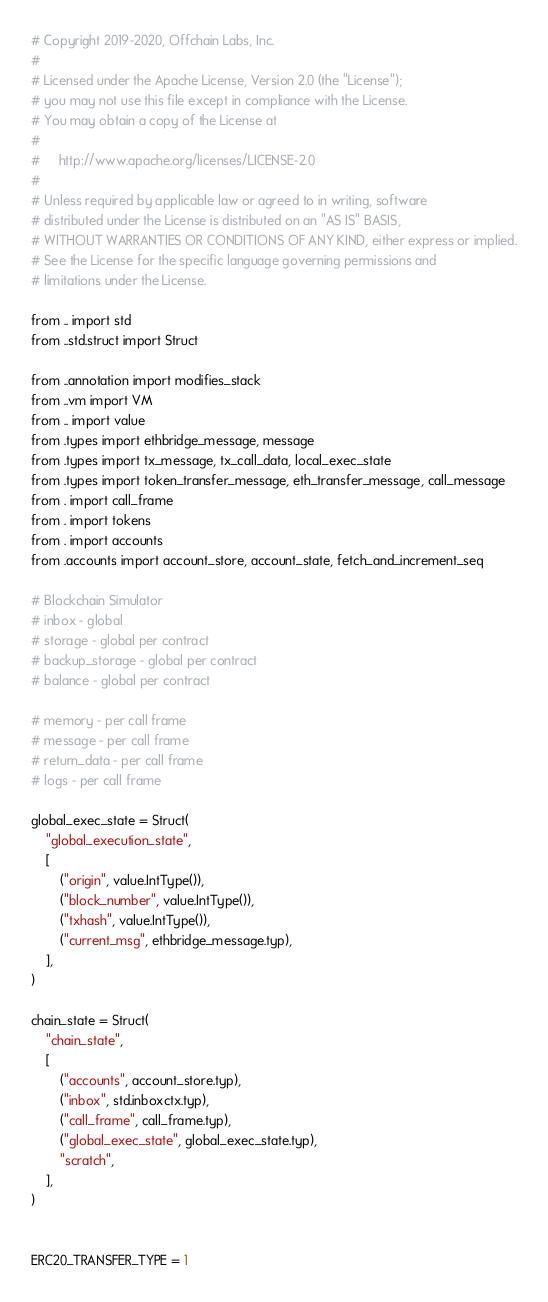<code> <loc_0><loc_0><loc_500><loc_500><_Python_># Copyright 2019-2020, Offchain Labs, Inc.
#
# Licensed under the Apache License, Version 2.0 (the "License");
# you may not use this file except in compliance with the License.
# You may obtain a copy of the License at
#
#     http://www.apache.org/licenses/LICENSE-2.0
#
# Unless required by applicable law or agreed to in writing, software
# distributed under the License is distributed on an "AS IS" BASIS,
# WITHOUT WARRANTIES OR CONDITIONS OF ANY KIND, either express or implied.
# See the License for the specific language governing permissions and
# limitations under the License.

from .. import std
from ..std.struct import Struct

from ..annotation import modifies_stack
from ..vm import VM
from .. import value
from .types import ethbridge_message, message
from .types import tx_message, tx_call_data, local_exec_state
from .types import token_transfer_message, eth_transfer_message, call_message
from . import call_frame
from . import tokens
from . import accounts
from .accounts import account_store, account_state, fetch_and_increment_seq

# Blockchain Simulator
# inbox - global
# storage - global per contract
# backup_storage - global per contract
# balance - global per contract

# memory - per call frame
# message - per call frame
# return_data - per call frame
# logs - per call frame

global_exec_state = Struct(
    "global_execution_state",
    [
        ("origin", value.IntType()),
        ("block_number", value.IntType()),
        ("txhash", value.IntType()),
        ("current_msg", ethbridge_message.typ),
    ],
)

chain_state = Struct(
    "chain_state",
    [
        ("accounts", account_store.typ),
        ("inbox", std.inboxctx.typ),
        ("call_frame", call_frame.typ),
        ("global_exec_state", global_exec_state.typ),
        "scratch",
    ],
)


ERC20_TRANSFER_TYPE = 1</code> 